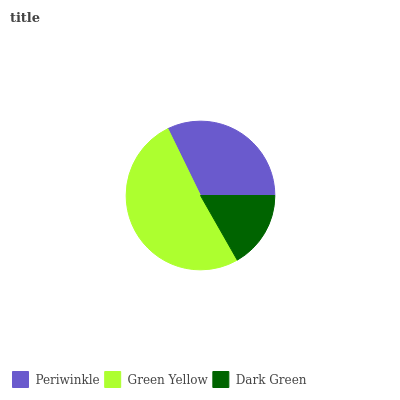Is Dark Green the minimum?
Answer yes or no. Yes. Is Green Yellow the maximum?
Answer yes or no. Yes. Is Green Yellow the minimum?
Answer yes or no. No. Is Dark Green the maximum?
Answer yes or no. No. Is Green Yellow greater than Dark Green?
Answer yes or no. Yes. Is Dark Green less than Green Yellow?
Answer yes or no. Yes. Is Dark Green greater than Green Yellow?
Answer yes or no. No. Is Green Yellow less than Dark Green?
Answer yes or no. No. Is Periwinkle the high median?
Answer yes or no. Yes. Is Periwinkle the low median?
Answer yes or no. Yes. Is Green Yellow the high median?
Answer yes or no. No. Is Dark Green the low median?
Answer yes or no. No. 